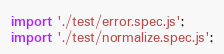Convert code to text. <code><loc_0><loc_0><loc_500><loc_500><_TypeScript_>import './test/error.spec.js';
import './test/normalize.spec.js';
</code> 